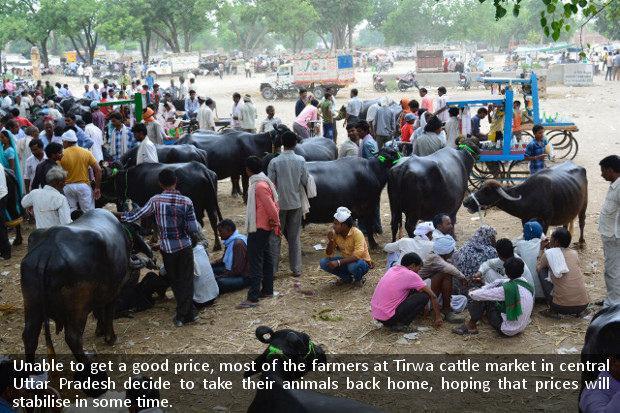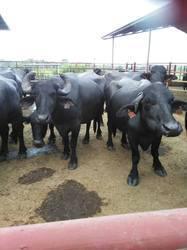The first image is the image on the left, the second image is the image on the right. Considering the images on both sides, is "One image shows cattle standing facing forward on dirt ground, with columns holding up a roof in the background but no people present." valid? Answer yes or no. Yes. The first image is the image on the left, the second image is the image on the right. Evaluate the accuracy of this statement regarding the images: "A crowd of people and cows gather together in a dirt surfaced area.". Is it true? Answer yes or no. Yes. 